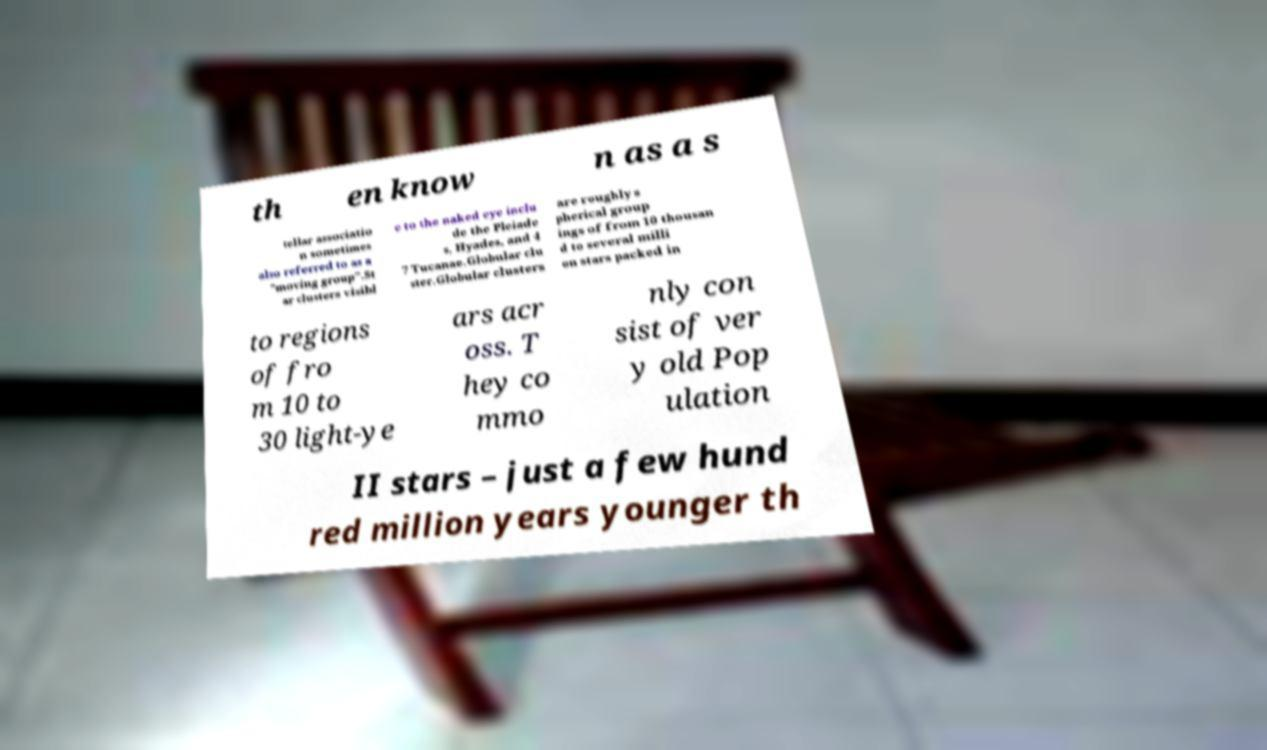Can you read and provide the text displayed in the image?This photo seems to have some interesting text. Can you extract and type it out for me? th en know n as a s tellar associatio n sometimes also referred to as a "moving group".St ar clusters visibl e to the naked eye inclu de the Pleiade s, Hyades, and 4 7 Tucanae.Globular clu ster.Globular clusters are roughly s pherical group ings of from 10 thousan d to several milli on stars packed in to regions of fro m 10 to 30 light-ye ars acr oss. T hey co mmo nly con sist of ver y old Pop ulation II stars – just a few hund red million years younger th 